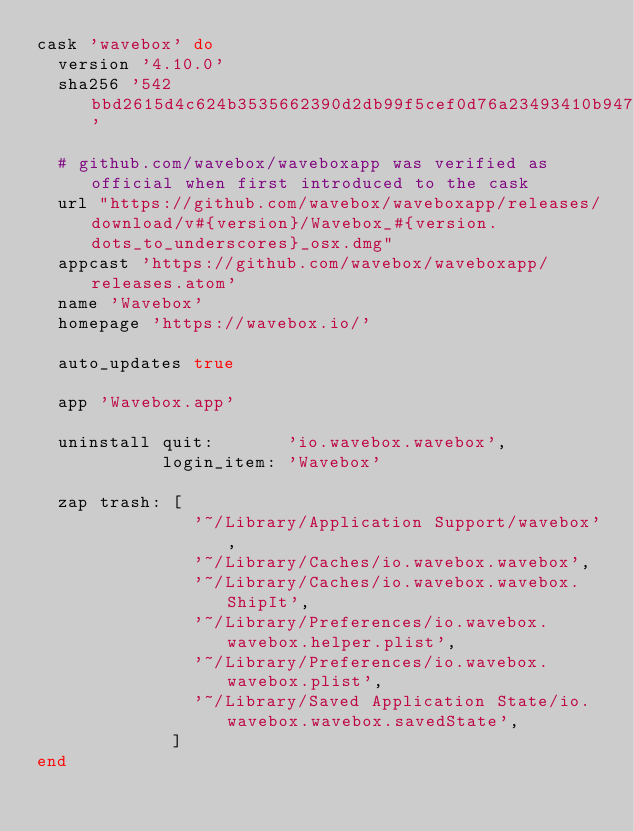Convert code to text. <code><loc_0><loc_0><loc_500><loc_500><_Ruby_>cask 'wavebox' do
  version '4.10.0'
  sha256 '542bbd2615d4c624b3535662390d2db99f5cef0d76a23493410b947cef5d611a'

  # github.com/wavebox/waveboxapp was verified as official when first introduced to the cask
  url "https://github.com/wavebox/waveboxapp/releases/download/v#{version}/Wavebox_#{version.dots_to_underscores}_osx.dmg"
  appcast 'https://github.com/wavebox/waveboxapp/releases.atom'
  name 'Wavebox'
  homepage 'https://wavebox.io/'

  auto_updates true

  app 'Wavebox.app'

  uninstall quit:       'io.wavebox.wavebox',
            login_item: 'Wavebox'

  zap trash: [
               '~/Library/Application Support/wavebox',
               '~/Library/Caches/io.wavebox.wavebox',
               '~/Library/Caches/io.wavebox.wavebox.ShipIt',
               '~/Library/Preferences/io.wavebox.wavebox.helper.plist',
               '~/Library/Preferences/io.wavebox.wavebox.plist',
               '~/Library/Saved Application State/io.wavebox.wavebox.savedState',
             ]
end
</code> 